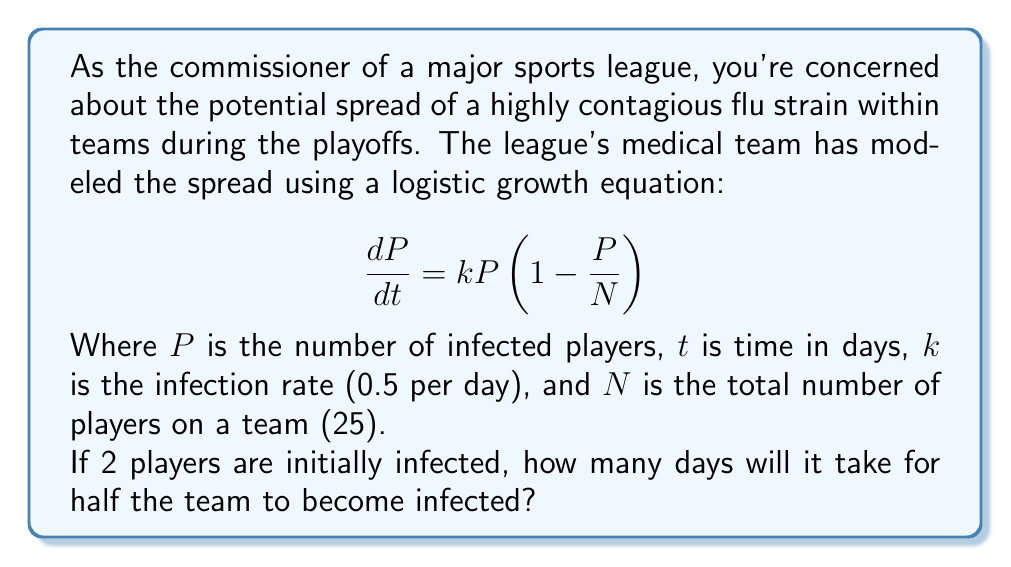Can you answer this question? To solve this problem, we need to use the logistic growth equation and find the time when $P = 12.5$ (half of 25 players). Let's approach this step-by-step:

1) The solution to the logistic growth equation is:

   $$P(t) = \frac{N}{1 + (\frac{N}{P_0} - 1)e^{-kt}}$$

   Where $P_0$ is the initial number of infected players.

2) We know:
   $N = 25$ (total players)
   $k = 0.5$ (infection rate per day)
   $P_0 = 2$ (initial infected players)
   $P(t) = 12.5$ (target infected players)

3) Let's substitute these values into the equation:

   $$12.5 = \frac{25}{1 + (\frac{25}{2} - 1)e^{-0.5t}}$$

4) Simplify:
   $$12.5 = \frac{25}{1 + 11.5e^{-0.5t}}$$

5) Multiply both sides by $(1 + 11.5e^{-0.5t})$:
   $$12.5 + 143.75e^{-0.5t} = 25$$

6) Subtract 12.5 from both sides:
   $$143.75e^{-0.5t} = 12.5$$

7) Divide both sides by 143.75:
   $$e^{-0.5t} = \frac{12.5}{143.75} = \frac{1}{11.5}$$

8) Take the natural log of both sides:
   $$-0.5t = \ln(\frac{1}{11.5}) = -\ln(11.5)$$

9) Divide both sides by -0.5:
   $$t = \frac{\ln(11.5)}{0.5} \approx 4.88$$

Therefore, it will take approximately 4.88 days for half the team to become infected.
Answer: Approximately 4.88 days 